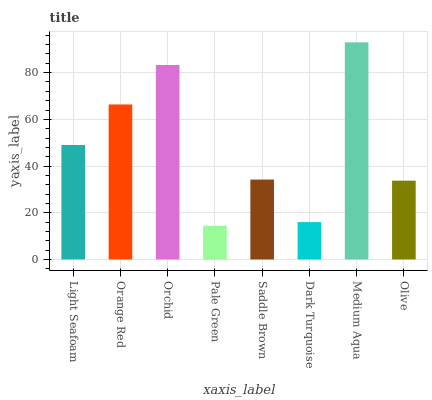Is Pale Green the minimum?
Answer yes or no. Yes. Is Medium Aqua the maximum?
Answer yes or no. Yes. Is Orange Red the minimum?
Answer yes or no. No. Is Orange Red the maximum?
Answer yes or no. No. Is Orange Red greater than Light Seafoam?
Answer yes or no. Yes. Is Light Seafoam less than Orange Red?
Answer yes or no. Yes. Is Light Seafoam greater than Orange Red?
Answer yes or no. No. Is Orange Red less than Light Seafoam?
Answer yes or no. No. Is Light Seafoam the high median?
Answer yes or no. Yes. Is Saddle Brown the low median?
Answer yes or no. Yes. Is Olive the high median?
Answer yes or no. No. Is Medium Aqua the low median?
Answer yes or no. No. 